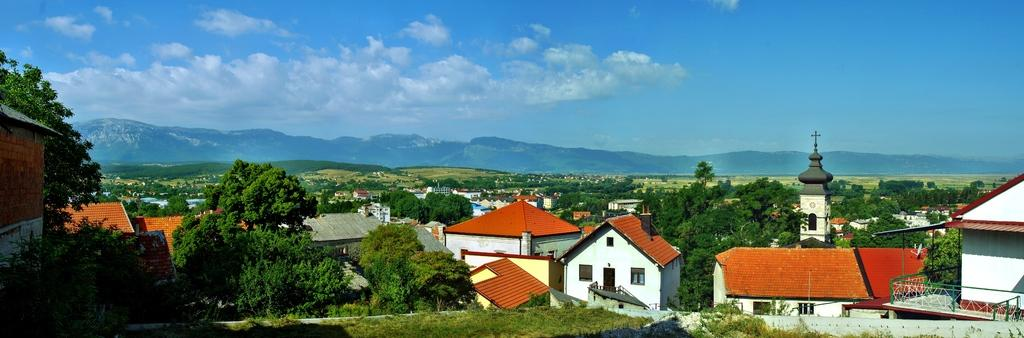What type of buildings can be seen in the image? There are houses in the image. What religious building is located on the right side of the image? There is a church on the right side of the image. What type of vegetation is on the left side of the image? There are green color trees on the left side of the image. What is visible at the top of the image? The sky is visible at the top of the image. Where is the airport located in the image? There is no airport present in the image. Can you tell me how many horses are depicted in the image? There are no horses depicted in the image. 